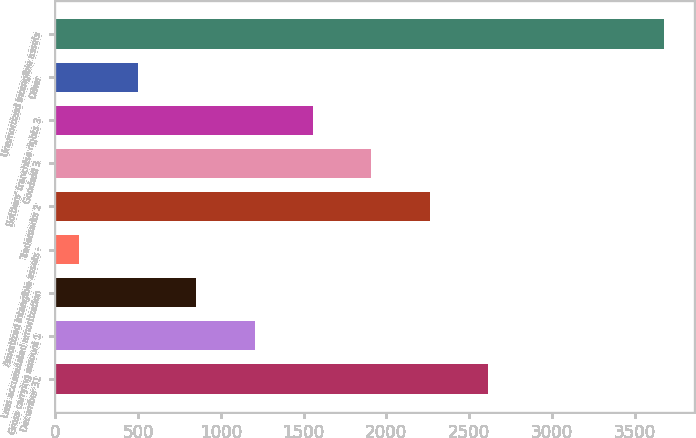<chart> <loc_0><loc_0><loc_500><loc_500><bar_chart><fcel>December 31<fcel>Gross carrying amount 1<fcel>Less accumulated amortization<fcel>Amortized intangible assets -<fcel>Trademarks 2<fcel>Goodwill 3<fcel>Bottlers' franchise rights 3<fcel>Other<fcel>Unamortized intangible assets<nl><fcel>2616.3<fcel>1204.7<fcel>851.8<fcel>146<fcel>2263.4<fcel>1910.5<fcel>1557.6<fcel>498.9<fcel>3675<nl></chart> 